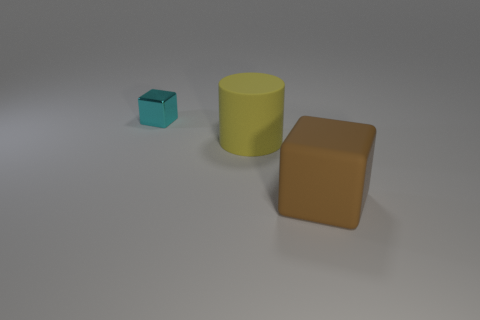Add 2 matte things. How many objects exist? 5 Subtract all cubes. How many objects are left? 1 Subtract all green spheres. How many blue cylinders are left? 0 Subtract all purple cubes. Subtract all blue spheres. How many cubes are left? 2 Subtract all big yellow things. Subtract all cyan matte blocks. How many objects are left? 2 Add 1 cylinders. How many cylinders are left? 2 Add 2 large yellow cylinders. How many large yellow cylinders exist? 3 Subtract 0 purple balls. How many objects are left? 3 